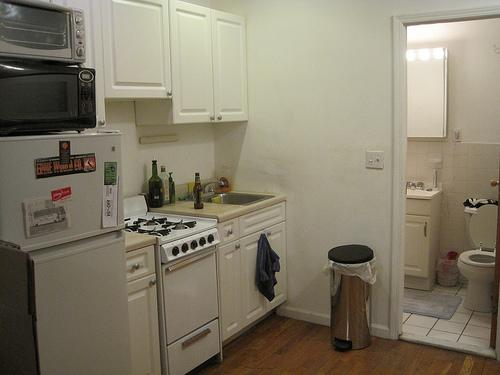What type of flooring is present in the image and what items are found on the floor? There is a tile floor and a hardwood floor, on which a bathroom mat and white floor tiles are found. Provide a brief analysis of the context of the image. The image depicts a combined kitchen and bathroom setting, with various items like a white kitchen, white refrigerator, black microwave, white toaster oven, clean white stove, toilet, bathroom mat, hardwood and tile floors, and a chrome trash can. Are there any bathroom items that can be found in the image? If so, list them. Toilet with lid up, white toilet seat, white cupboard doors, a bathroom mat, light switches on the wall, bathroom lights on, and the bathroom with the door open. List all the items related to kitchen in the given image. Kitchen, white refrigerator, black microwave, white toaster oven, clean white stove, toaster oven on top, plastic bottle of dish washing liquid, gas oven, white stove for cooking, white cupboard doors, metal handle of cabinet, handles for cupboards, towel for kitchen, wine bottle that's open, kitchen and bathroom together, the kitchen is white, the floor is tile, a shiny metal garbage can, grey trash can, the micro wave is black, the microwave is white. If this image was given for image segmentation, what groups of items can be separated from each other? Main groups for image segmentation could include kitchen appliances, bathroom items, flooring types, and storage-related items like cupboard doors and handles. Identify and describe three features of the trash can in the image. The trash can is chrome, the lid of the can is black, and there is a garbage bag covering it. Describe the sentiment or mood of the image based on the items present. The image feels clean, organized, and peaceful, with neat and orderly kitchen items and bathroom accessories. What color is the main kitchen in the image and what is the main bathroom like? The main kitchen is white, and the main bathroom has the door open and lights on. Is there anything unusual or unexpected in the image? If so, describe it briefly. It is unusual to find a kitchen and bathroom together, as they are typically separated in most homes. Based on the descriptions provided, what sort of reasoning task can be performed on the image? A complex reasoning task can be performed, including determining the relationship between various items in the combined kitchen and bathroom setting and analyzing their functionalities and purposes. Are the bathroom lights switched on? Yes Can you tell me the time displayed on the clock hanging on the wall between the kitchen and bathroom? No, it's not mentioned in the image. Is there a refrigerator in the scene? If so, what color is it? Yes, the refrigerator is white. Analyze the interaction between the bottles and the counter. Bottles are placed on the counter. Describe the scene in a poetic way. A kitchen of white, a bathroom adjoining, the intersection of life's nourishment and cleansing Describe the oven's appearance. Clean white stove for cooking Which room has a white cupboard door? Kitchen Which object is standing on the floor? The trash can is standing on the floor. Locate the light switches in the image. On the wall Identify the items on the floor in the bathroom. A bathroom mat Describe the scene as an old-fashioned painting. An intimate portrait of domestic life, contrasting a pristine kitchen with a warmly lit bathroom Identify the object on the counter. Bottles What type of room is the door open to? Bathroom Analyze the interaction between the trashcan and the garbage bag. The garbage bag is covering the trashcan. Locate a towel in the image and describe it. Dark blue drying towel in the kitchen What is the color of the kitchen? White 